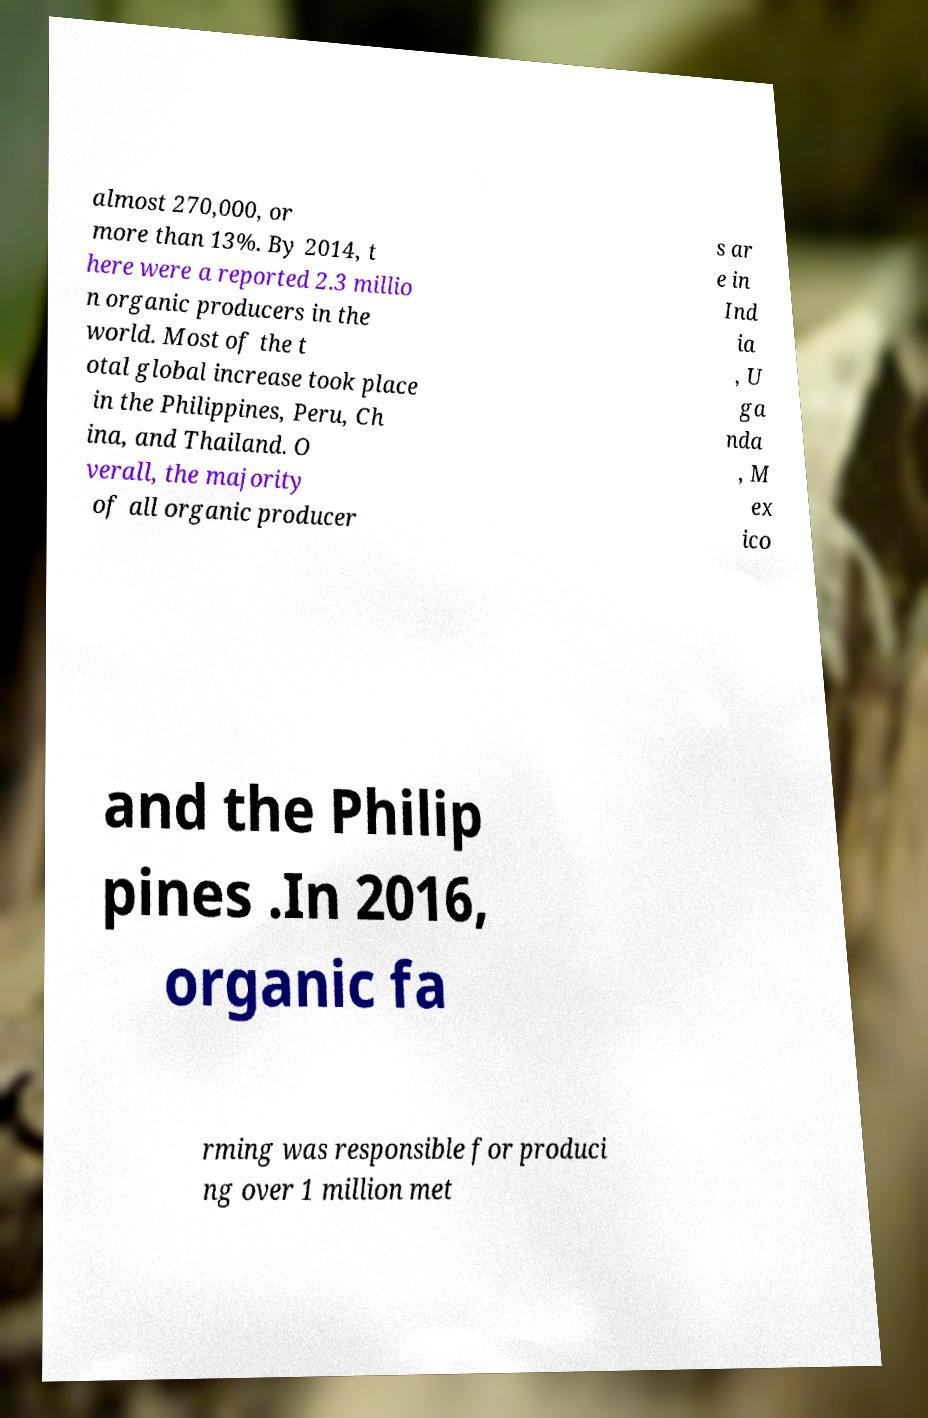I need the written content from this picture converted into text. Can you do that? almost 270,000, or more than 13%. By 2014, t here were a reported 2.3 millio n organic producers in the world. Most of the t otal global increase took place in the Philippines, Peru, Ch ina, and Thailand. O verall, the majority of all organic producer s ar e in Ind ia , U ga nda , M ex ico and the Philip pines .In 2016, organic fa rming was responsible for produci ng over 1 million met 